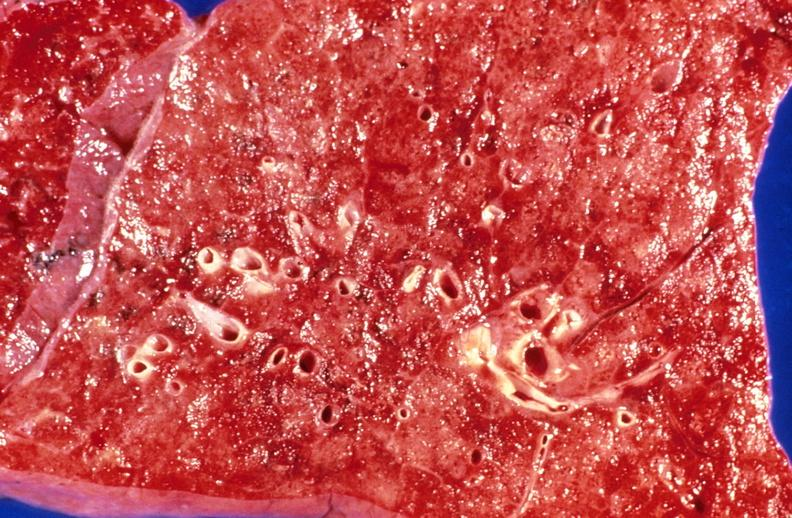does all the fat necrosis show aspiration pneumonia, acute alcoholic?
Answer the question using a single word or phrase. No 